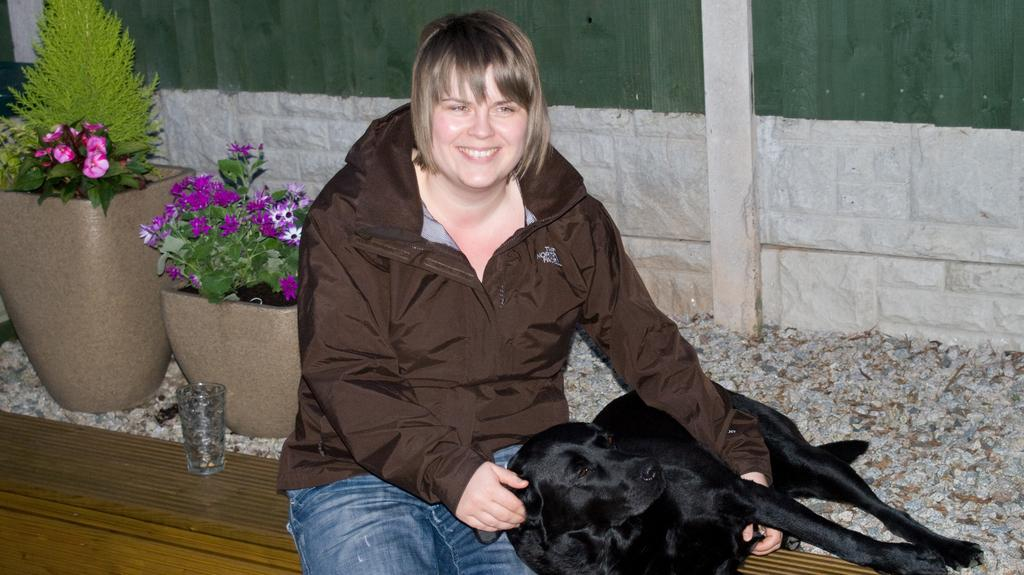What is the main subject in the middle of the image? There is a woman sitting in the middle of the image. What is the woman holding in the image? The woman is holding a dog. What can be seen on the left side of the image? There is a glass and houseplants on the left side of the image. What type of calculator is being used by the dog in the image? There is no calculator present in the image, and the dog is not using any device. 